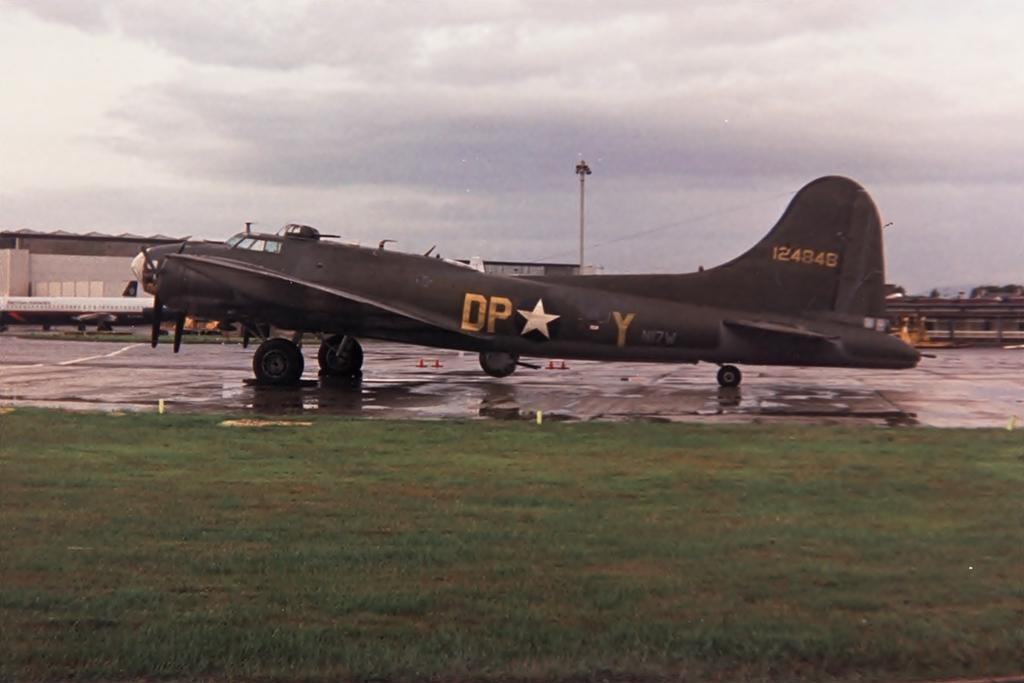<image>
Share a concise interpretation of the image provided. a plane with the letters DP on the side of it 